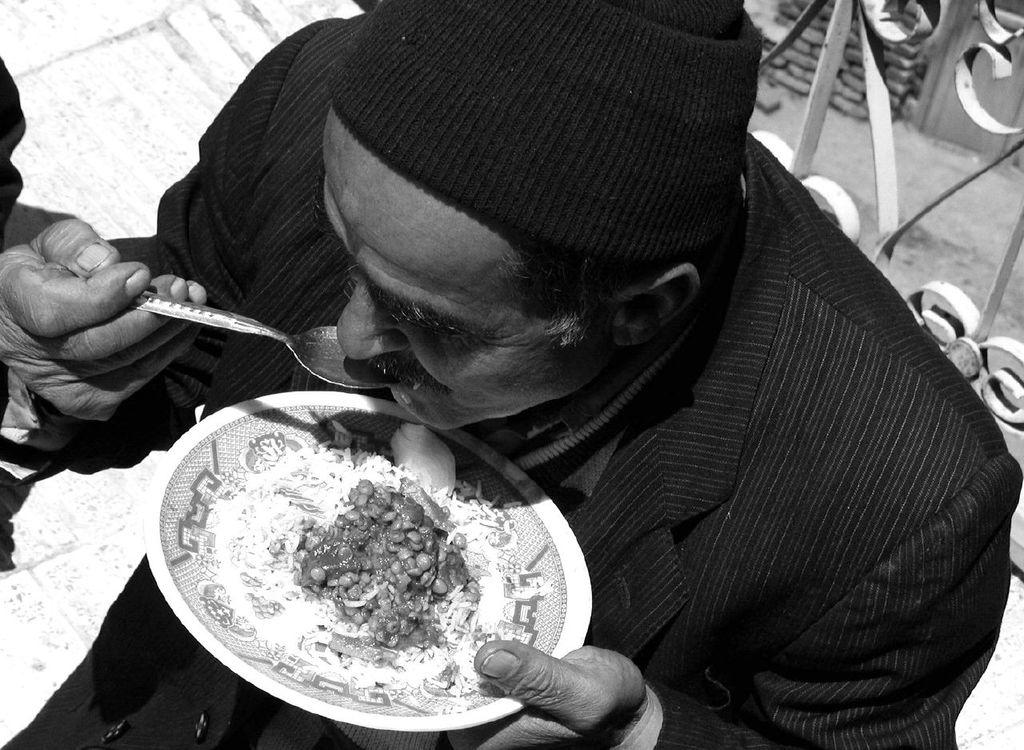What is the color scheme of the image? The image is black and white. Who is present in the image? There is a man in the image. What is the man holding in the image? The man is holding a plate. What is the man doing with the plate? The man is eating food with a spoon. What type of surface is visible in the image? There is a floor in the image. What other structures are visible in the image? There is a wall and a road in the image. Can you see the man's wing in the image? There is no wing present in the image; it features a man holding a plate and eating food with a spoon. What type of record is the man breaking in the image? There is no record-breaking activity depicted in the image; it simply shows a man eating food with a spoon. 